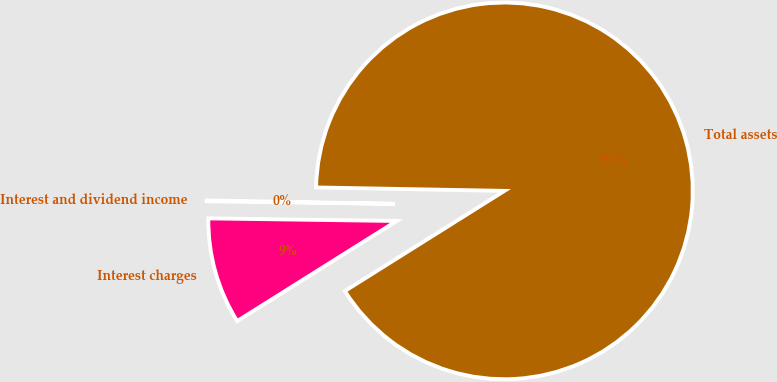Convert chart. <chart><loc_0><loc_0><loc_500><loc_500><pie_chart><fcel>Interest charges<fcel>Total assets<fcel>Interest and dividend income<nl><fcel>9.14%<fcel>90.79%<fcel>0.07%<nl></chart> 